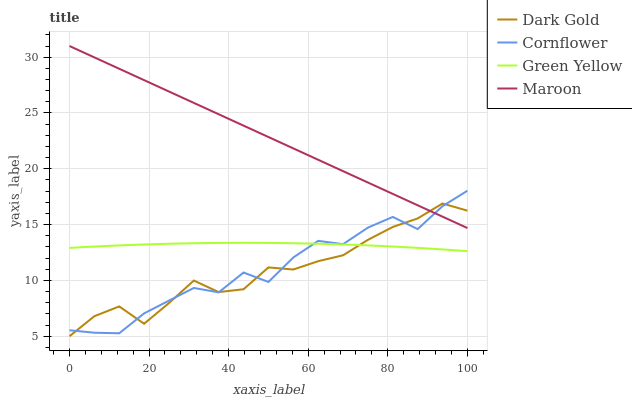Does Dark Gold have the minimum area under the curve?
Answer yes or no. Yes. Does Maroon have the maximum area under the curve?
Answer yes or no. Yes. Does Green Yellow have the minimum area under the curve?
Answer yes or no. No. Does Green Yellow have the maximum area under the curve?
Answer yes or no. No. Is Maroon the smoothest?
Answer yes or no. Yes. Is Cornflower the roughest?
Answer yes or no. Yes. Is Green Yellow the smoothest?
Answer yes or no. No. Is Green Yellow the roughest?
Answer yes or no. No. Does Dark Gold have the lowest value?
Answer yes or no. Yes. Does Green Yellow have the lowest value?
Answer yes or no. No. Does Maroon have the highest value?
Answer yes or no. Yes. Does Green Yellow have the highest value?
Answer yes or no. No. Is Green Yellow less than Maroon?
Answer yes or no. Yes. Is Maroon greater than Green Yellow?
Answer yes or no. Yes. Does Cornflower intersect Maroon?
Answer yes or no. Yes. Is Cornflower less than Maroon?
Answer yes or no. No. Is Cornflower greater than Maroon?
Answer yes or no. No. Does Green Yellow intersect Maroon?
Answer yes or no. No. 